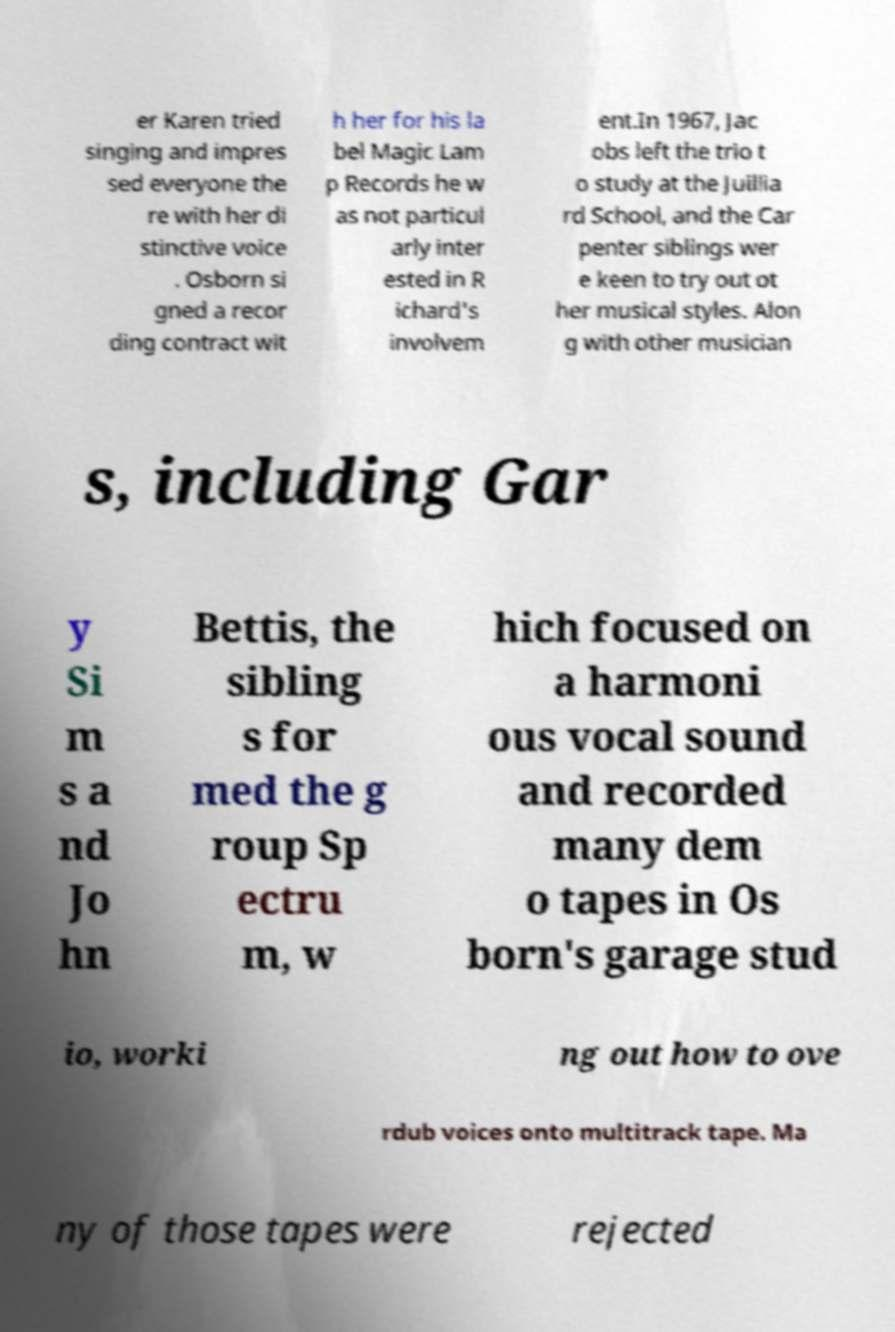Could you extract and type out the text from this image? er Karen tried singing and impres sed everyone the re with her di stinctive voice . Osborn si gned a recor ding contract wit h her for his la bel Magic Lam p Records he w as not particul arly inter ested in R ichard's involvem ent.In 1967, Jac obs left the trio t o study at the Juillia rd School, and the Car penter siblings wer e keen to try out ot her musical styles. Alon g with other musician s, including Gar y Si m s a nd Jo hn Bettis, the sibling s for med the g roup Sp ectru m, w hich focused on a harmoni ous vocal sound and recorded many dem o tapes in Os born's garage stud io, worki ng out how to ove rdub voices onto multitrack tape. Ma ny of those tapes were rejected 